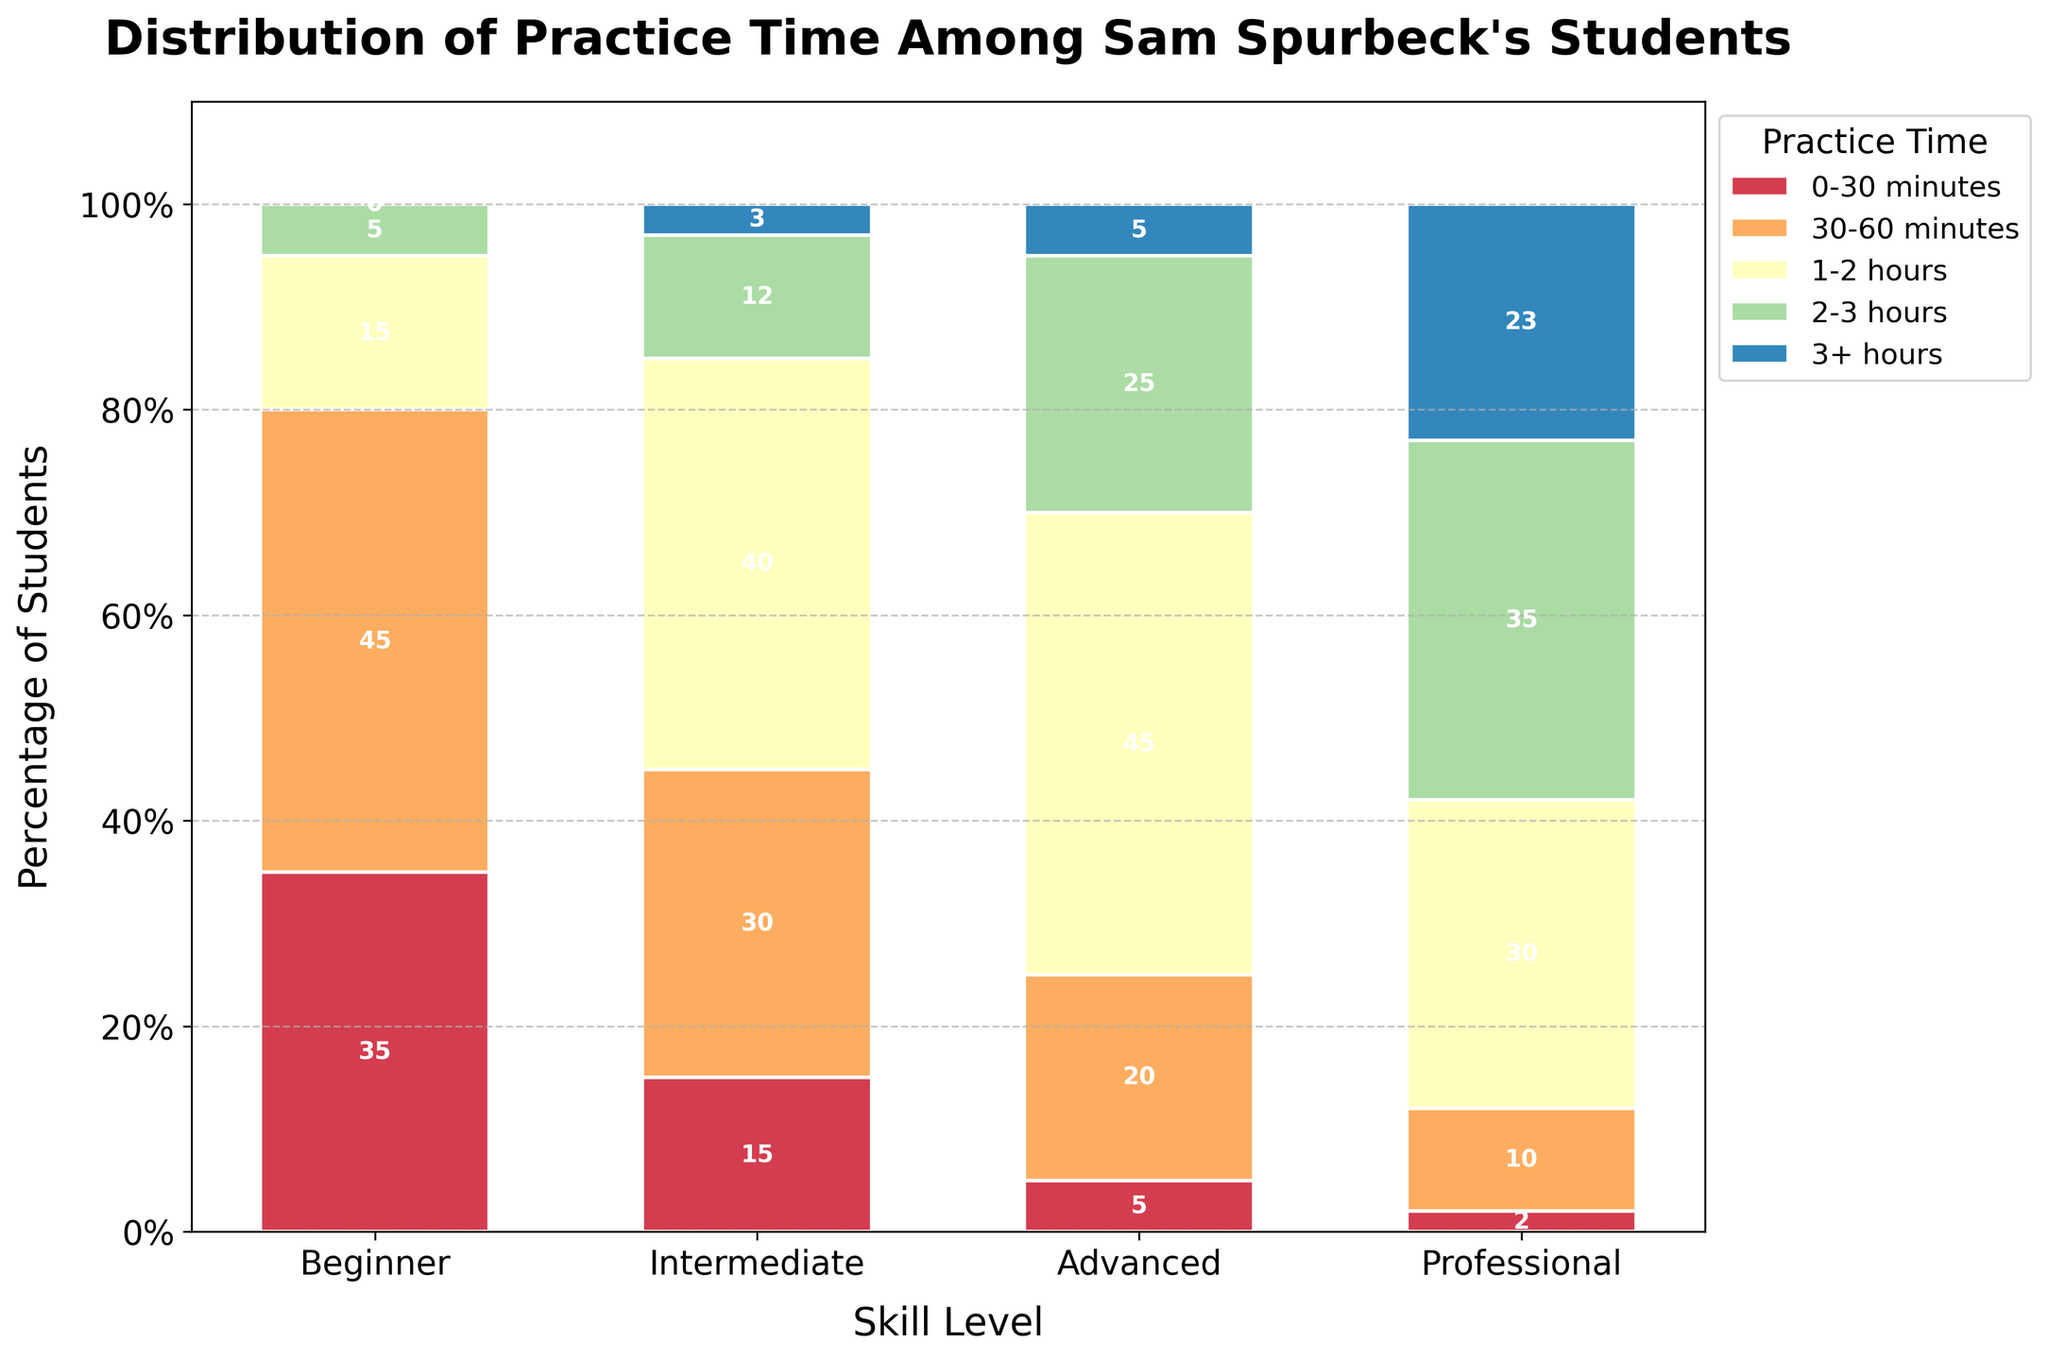What percentage of advanced students practice for 2-3 hours? To find the percentage of advanced students who practice for 2-3 hours, look at the value under the "2-3 hours" row and "Advanced" column.
Answer: 25% Among beginners, which practice duration has the highest percentage of students? Check the values for different practice times in the "Beginner" column and find the highest value.
Answer: 30-60 minutes How much more percentage do professional students spend practicing 3+ hours compared to intermediate students? Subtract the percentage of intermediate students practicing 3+ hours from that of professional students in the "3+ hours" row. 23% (professionals) - 3% (intermediate) = 20% more.
Answer: 20% What is the combined percentage of professional students practicing 1-2 hours and 2-3 hours daily? Add the percentages of professional students practicing 1-2 hours and 2-3 hours from the respective rows. 30% + 35% = 65%.
Answer: 65% Which skill level has the smallest percentage of students practicing 0-30 minutes? Identify the smallest value in the "0-30 minutes" row across all skill levels.
Answer: Professional (2%) Is there a skill level where exactly 45% of students practice 1-2 hours daily? Check the "1-2 hours" row for a value of 45% across all skill levels. Advanced students practice 1-2 hours with 45%.
Answer: Advanced Compare the percentage of students practicing 30-60 minutes between beginners and intermediate levels. Look at the "30-60 minutes" value for both the beginner and intermediate columns. Beginners practice 30-60 minutes at 45%, intermediate at 30%, so beginners practice 15% more.
Answer: Beginners practice 15% more What is the total percentage of intermediate and advanced students who practice more than 2 hours daily? Sum the percentages of intermediate and advanced students practicing 2-3 hours and 3+ hours. 
Intermediate: 12% (2-3 hours) + 3% (3+ hours) = 15%.
Advanced: 25% (2-3 hours) + 5% (3+ hours) = 30%.
Total: 15% + 30% = 45%.
Answer: 45% Which practice time appears in the most skill levels with some percentage of students? Check the rows for the number of non-zero percentages across skill levels. All practice times (0-30 minutes, 30-60 minutes, 1-2 hours, 2-3 hours, 3+ hours) appear across all skill levels, but more clearly, the widest spread practice times are 1-2 hours as most percentages here are highest except at the beginner level.
Answer: 1-2 hours 